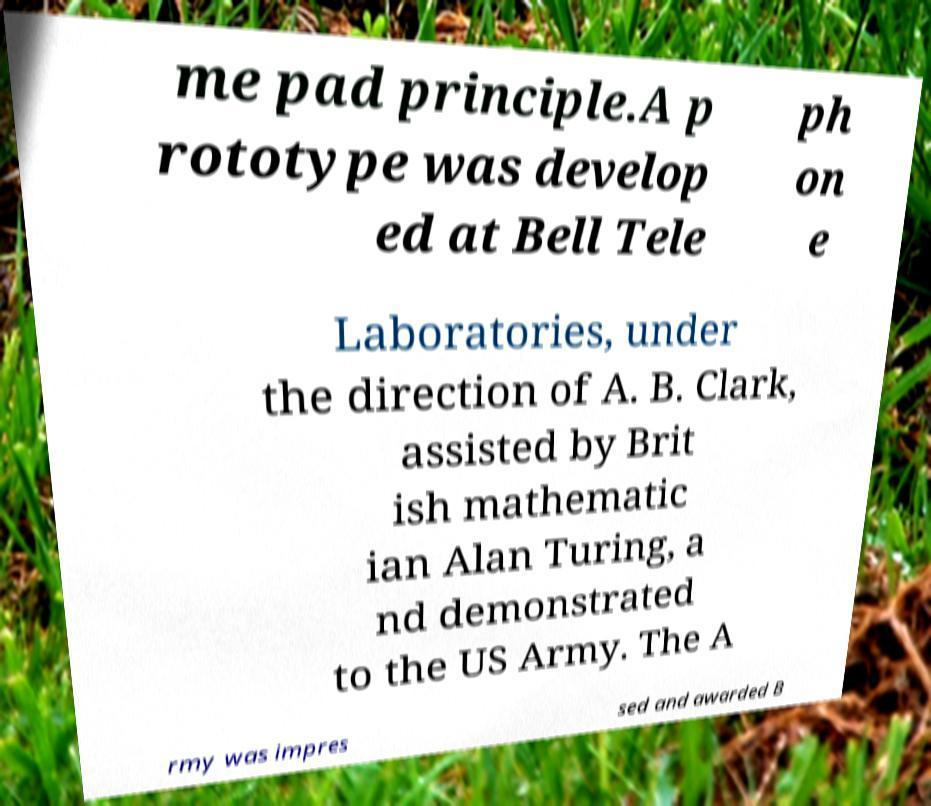Could you assist in decoding the text presented in this image and type it out clearly? me pad principle.A p rototype was develop ed at Bell Tele ph on e Laboratories, under the direction of A. B. Clark, assisted by Brit ish mathematic ian Alan Turing, a nd demonstrated to the US Army. The A rmy was impres sed and awarded B 